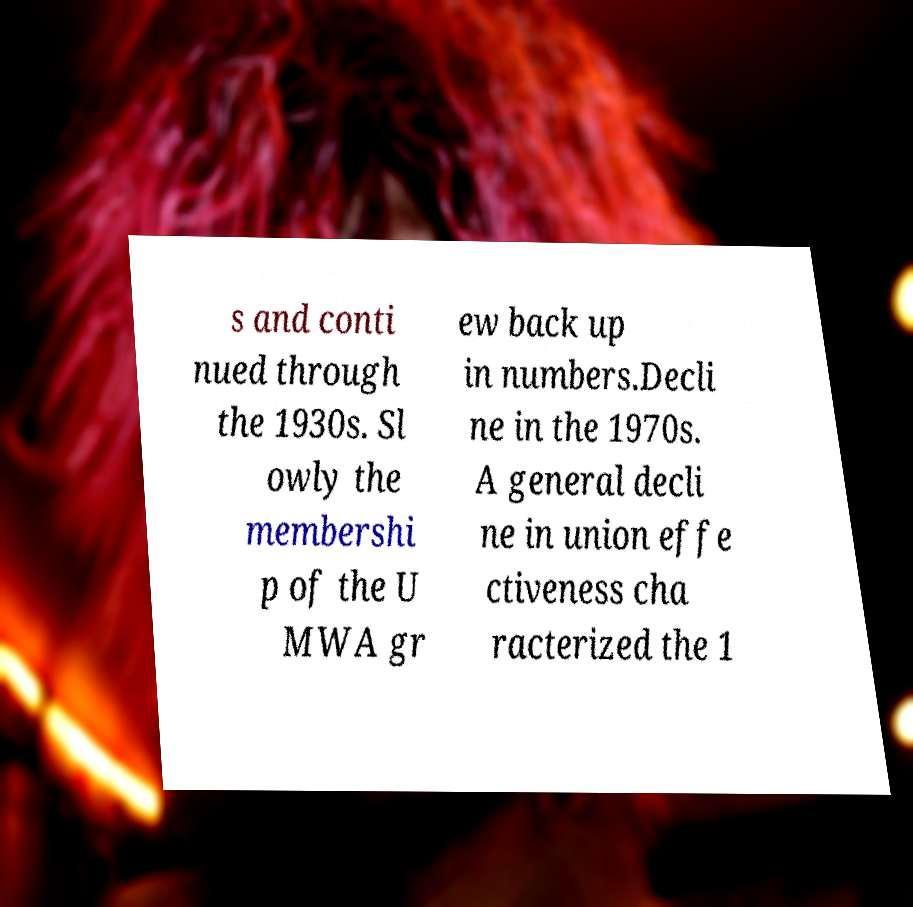I need the written content from this picture converted into text. Can you do that? s and conti nued through the 1930s. Sl owly the membershi p of the U MWA gr ew back up in numbers.Decli ne in the 1970s. A general decli ne in union effe ctiveness cha racterized the 1 